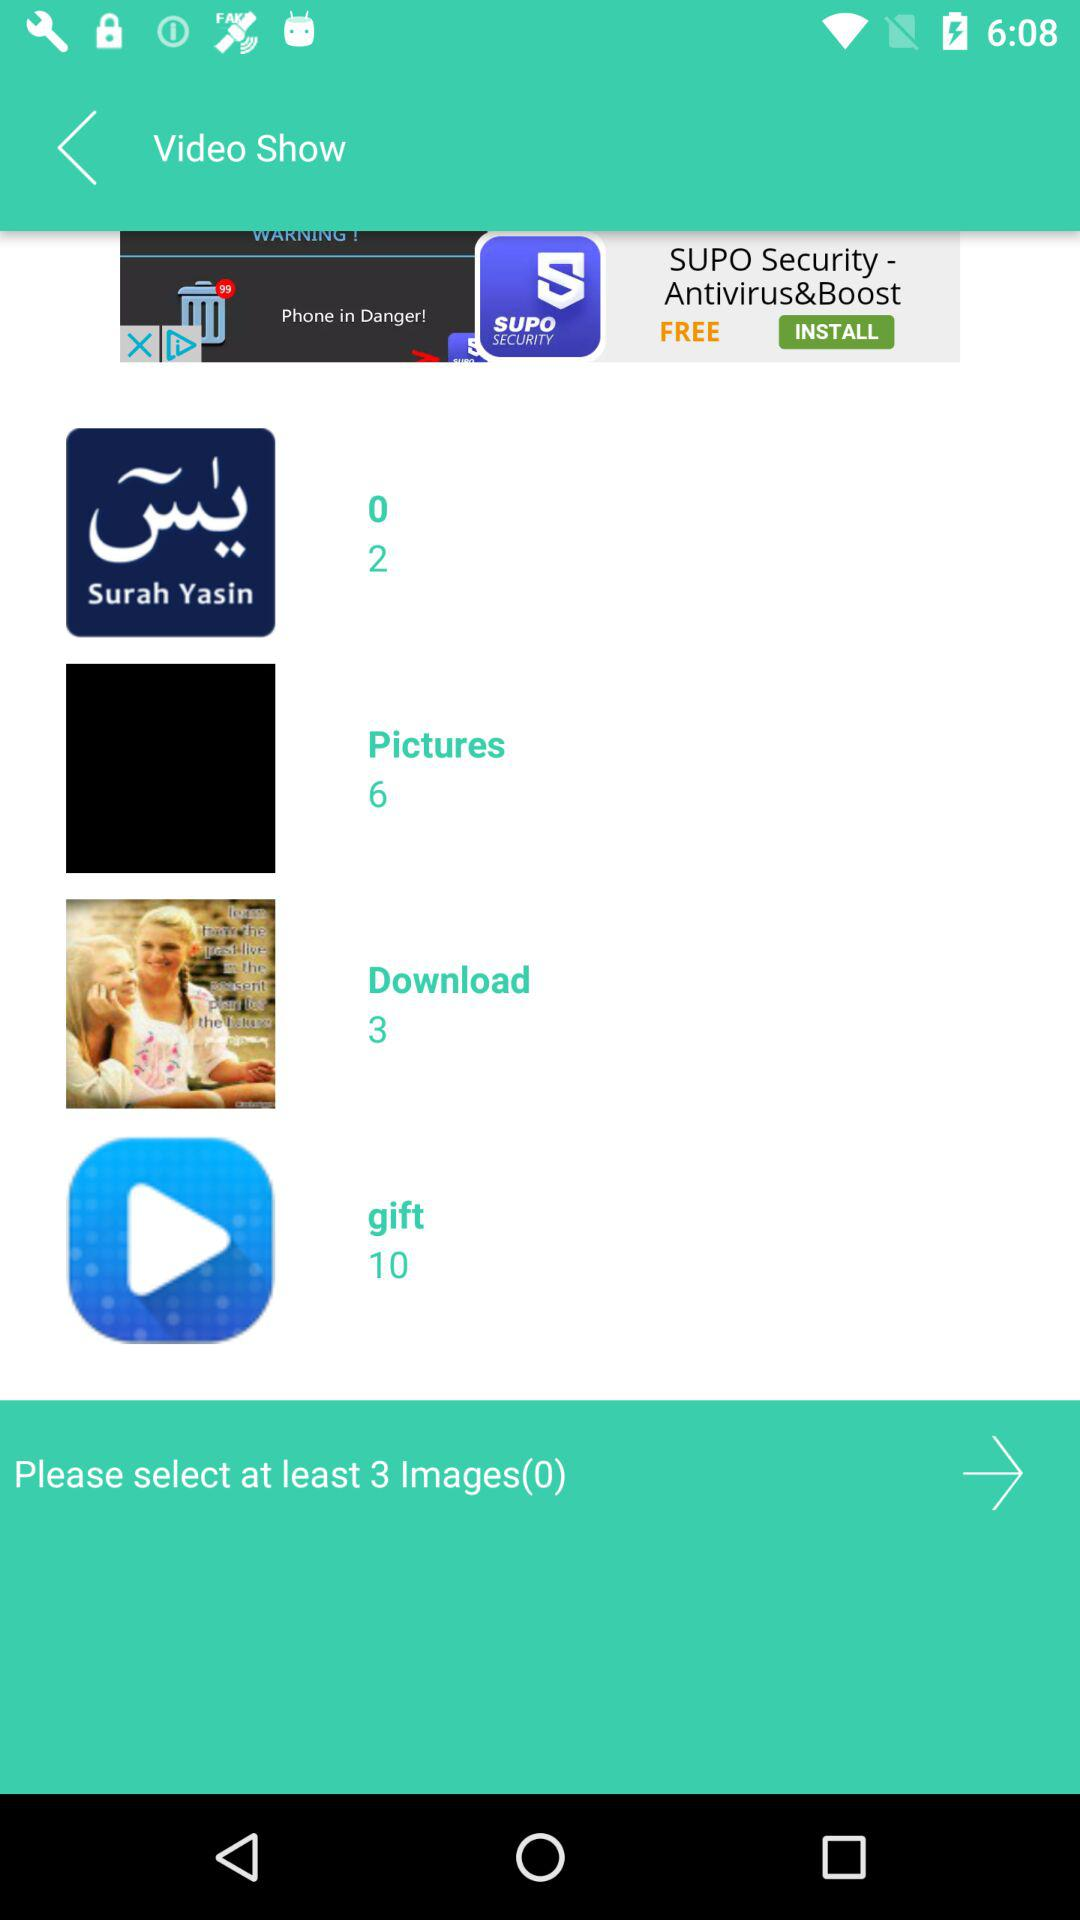How many images in total are there in the "Pictures" folder? There are 6 images in the "Pictures" folder. 